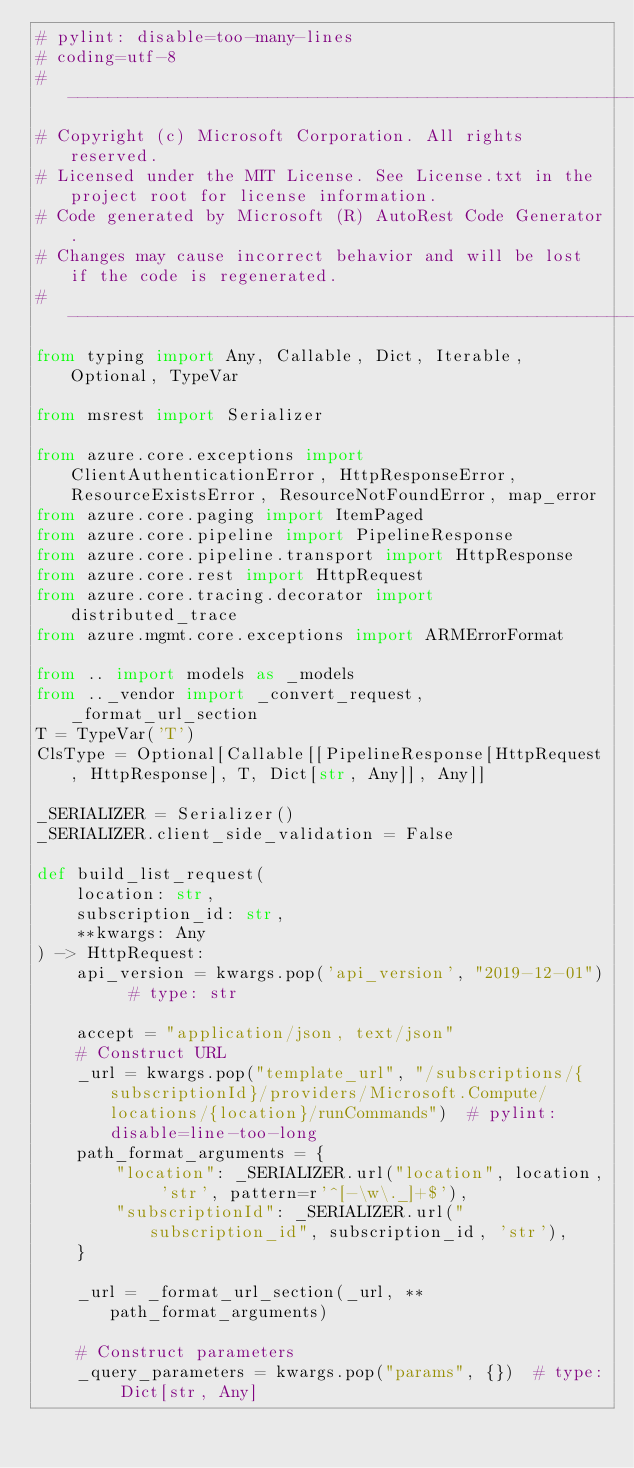<code> <loc_0><loc_0><loc_500><loc_500><_Python_># pylint: disable=too-many-lines
# coding=utf-8
# --------------------------------------------------------------------------
# Copyright (c) Microsoft Corporation. All rights reserved.
# Licensed under the MIT License. See License.txt in the project root for license information.
# Code generated by Microsoft (R) AutoRest Code Generator.
# Changes may cause incorrect behavior and will be lost if the code is regenerated.
# --------------------------------------------------------------------------
from typing import Any, Callable, Dict, Iterable, Optional, TypeVar

from msrest import Serializer

from azure.core.exceptions import ClientAuthenticationError, HttpResponseError, ResourceExistsError, ResourceNotFoundError, map_error
from azure.core.paging import ItemPaged
from azure.core.pipeline import PipelineResponse
from azure.core.pipeline.transport import HttpResponse
from azure.core.rest import HttpRequest
from azure.core.tracing.decorator import distributed_trace
from azure.mgmt.core.exceptions import ARMErrorFormat

from .. import models as _models
from .._vendor import _convert_request, _format_url_section
T = TypeVar('T')
ClsType = Optional[Callable[[PipelineResponse[HttpRequest, HttpResponse], T, Dict[str, Any]], Any]]

_SERIALIZER = Serializer()
_SERIALIZER.client_side_validation = False

def build_list_request(
    location: str,
    subscription_id: str,
    **kwargs: Any
) -> HttpRequest:
    api_version = kwargs.pop('api_version', "2019-12-01")  # type: str

    accept = "application/json, text/json"
    # Construct URL
    _url = kwargs.pop("template_url", "/subscriptions/{subscriptionId}/providers/Microsoft.Compute/locations/{location}/runCommands")  # pylint: disable=line-too-long
    path_format_arguments = {
        "location": _SERIALIZER.url("location", location, 'str', pattern=r'^[-\w\._]+$'),
        "subscriptionId": _SERIALIZER.url("subscription_id", subscription_id, 'str'),
    }

    _url = _format_url_section(_url, **path_format_arguments)

    # Construct parameters
    _query_parameters = kwargs.pop("params", {})  # type: Dict[str, Any]</code> 